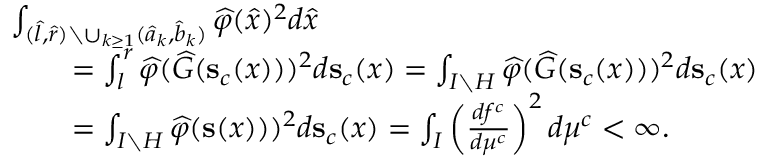Convert formula to latex. <formula><loc_0><loc_0><loc_500><loc_500>\begin{array} { r l } & { \int _ { ( \widehat { l } , \widehat { r } ) \ \cup _ { k \geq 1 } ( \widehat { a } _ { k } , \widehat { b } _ { k } ) } \widehat { \varphi } ( \widehat { x } ) ^ { 2 } d \widehat { x } } \\ & { \quad = \int _ { l } ^ { r } \widehat { \varphi } ( \widehat { G } ( s _ { c } ( x ) ) ) ^ { 2 } d s _ { c } ( x ) = \int _ { I \ H } \widehat { \varphi } ( \widehat { G } ( s _ { c } ( x ) ) ) ^ { 2 } d s _ { c } ( x ) } \\ & { \quad = \int _ { I \ H } \widehat { \varphi } ( s ( x ) ) ) ^ { 2 } d s _ { c } ( x ) = \int _ { I } \left ( \frac { d f ^ { c } } { d \mu ^ { c } } \right ) ^ { 2 } d \mu ^ { c } < \infty . } \end{array}</formula> 